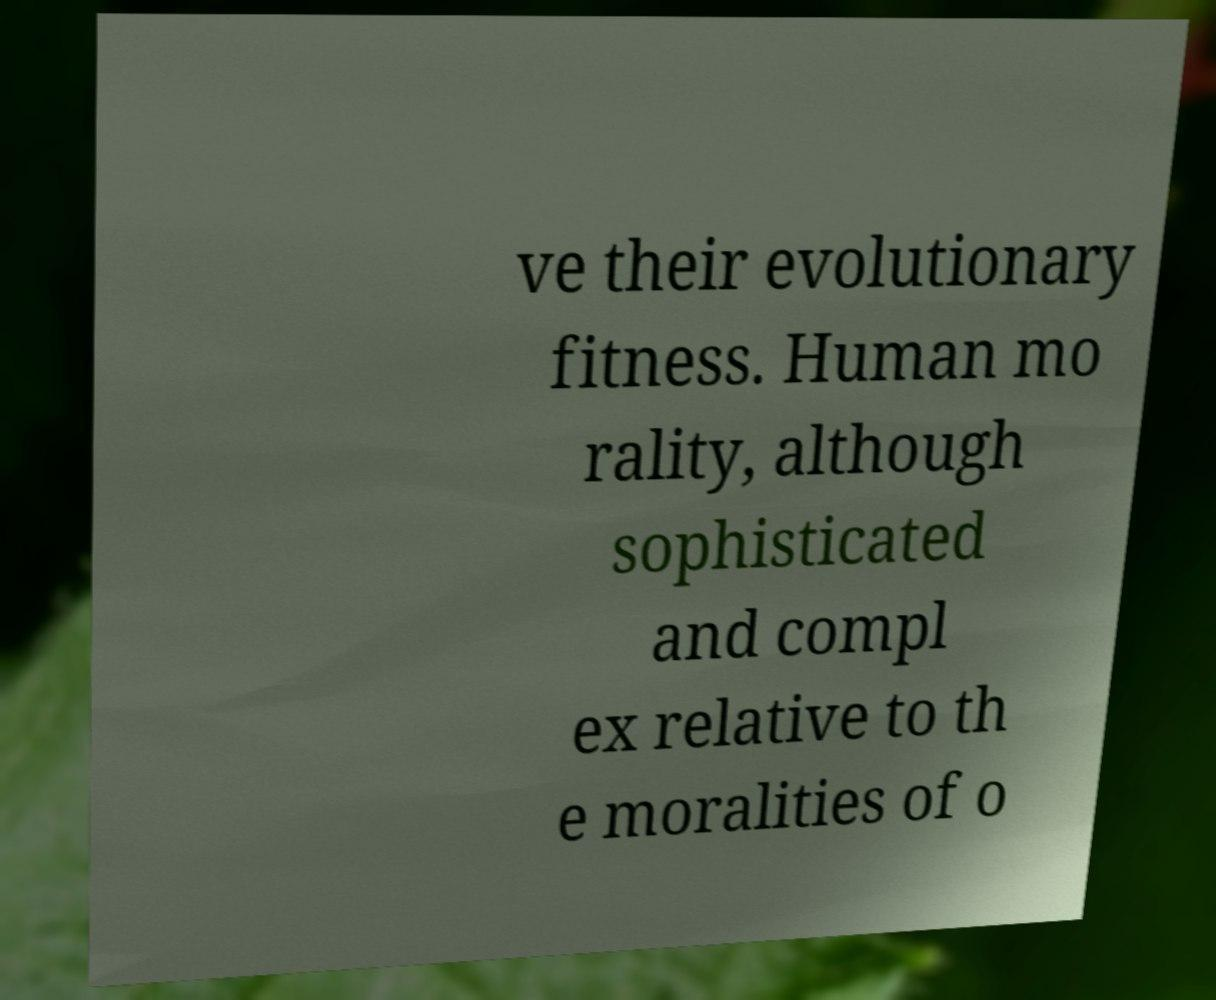Please read and relay the text visible in this image. What does it say? ve their evolutionary fitness. Human mo rality, although sophisticated and compl ex relative to th e moralities of o 